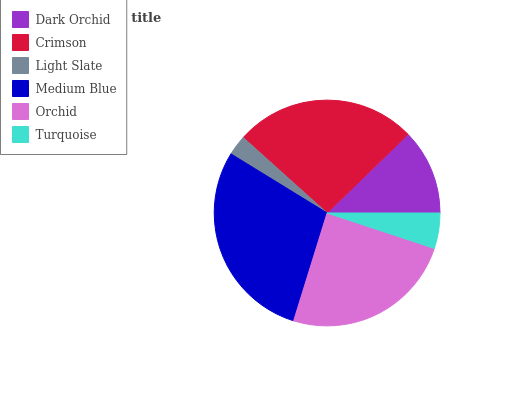Is Light Slate the minimum?
Answer yes or no. Yes. Is Medium Blue the maximum?
Answer yes or no. Yes. Is Crimson the minimum?
Answer yes or no. No. Is Crimson the maximum?
Answer yes or no. No. Is Crimson greater than Dark Orchid?
Answer yes or no. Yes. Is Dark Orchid less than Crimson?
Answer yes or no. Yes. Is Dark Orchid greater than Crimson?
Answer yes or no. No. Is Crimson less than Dark Orchid?
Answer yes or no. No. Is Orchid the high median?
Answer yes or no. Yes. Is Dark Orchid the low median?
Answer yes or no. Yes. Is Dark Orchid the high median?
Answer yes or no. No. Is Light Slate the low median?
Answer yes or no. No. 